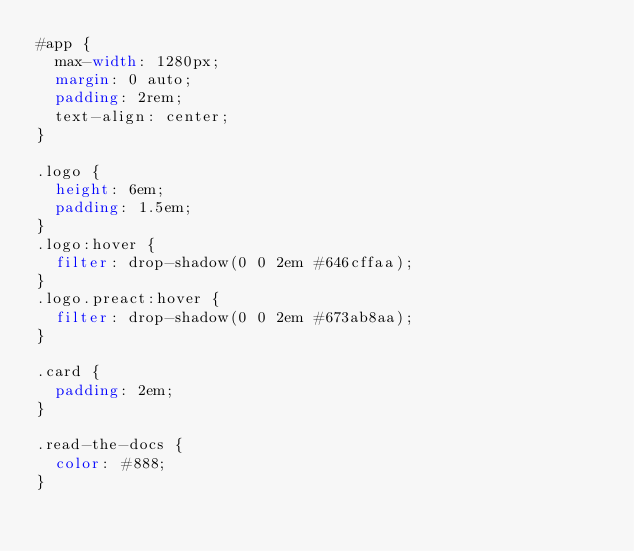<code> <loc_0><loc_0><loc_500><loc_500><_CSS_>#app {
  max-width: 1280px;
  margin: 0 auto;
  padding: 2rem;
  text-align: center;
}

.logo {
  height: 6em;
  padding: 1.5em;
}
.logo:hover {
  filter: drop-shadow(0 0 2em #646cffaa);
}
.logo.preact:hover {
  filter: drop-shadow(0 0 2em #673ab8aa);
}

.card {
  padding: 2em;
}

.read-the-docs {
  color: #888;
}
</code> 